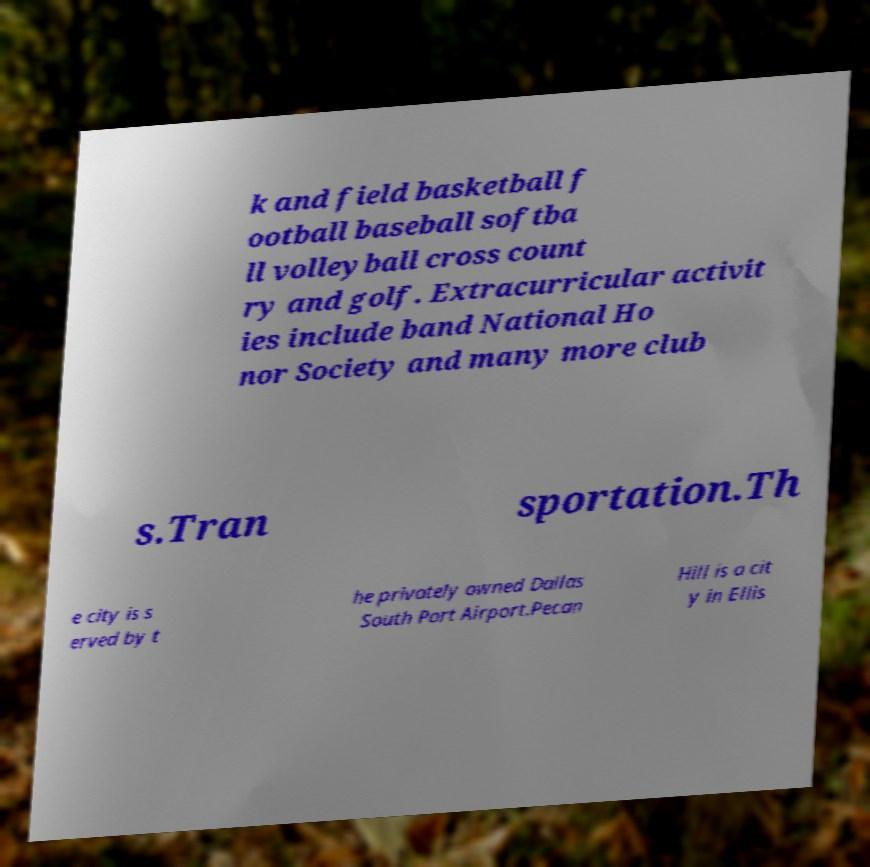Can you accurately transcribe the text from the provided image for me? k and field basketball f ootball baseball softba ll volleyball cross count ry and golf. Extracurricular activit ies include band National Ho nor Society and many more club s.Tran sportation.Th e city is s erved by t he privately owned Dallas South Port Airport.Pecan Hill is a cit y in Ellis 